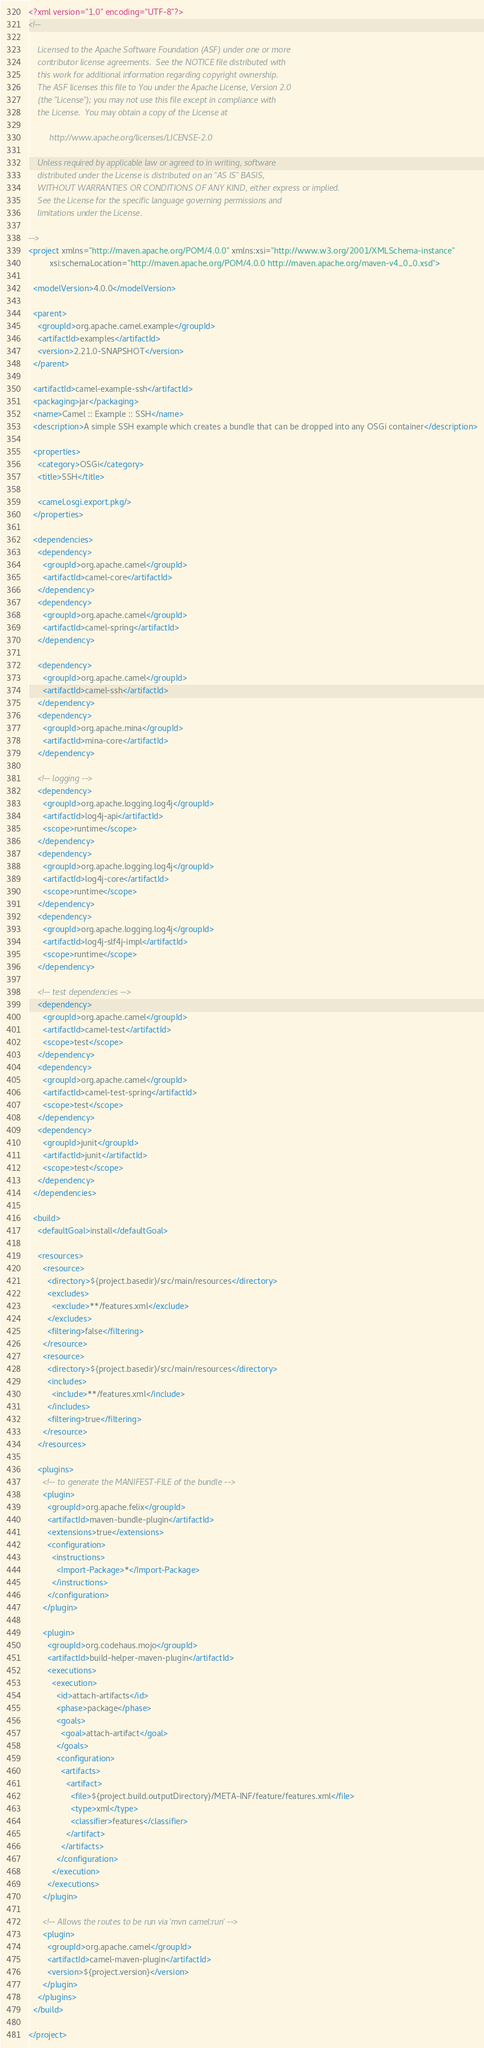<code> <loc_0><loc_0><loc_500><loc_500><_XML_><?xml version="1.0" encoding="UTF-8"?>
<!--

    Licensed to the Apache Software Foundation (ASF) under one or more
    contributor license agreements.  See the NOTICE file distributed with
    this work for additional information regarding copyright ownership.
    The ASF licenses this file to You under the Apache License, Version 2.0
    (the "License"); you may not use this file except in compliance with
    the License.  You may obtain a copy of the License at

         http://www.apache.org/licenses/LICENSE-2.0

    Unless required by applicable law or agreed to in writing, software
    distributed under the License is distributed on an "AS IS" BASIS,
    WITHOUT WARRANTIES OR CONDITIONS OF ANY KIND, either express or implied.
    See the License for the specific language governing permissions and
    limitations under the License.

-->
<project xmlns="http://maven.apache.org/POM/4.0.0" xmlns:xsi="http://www.w3.org/2001/XMLSchema-instance"
         xsi:schemaLocation="http://maven.apache.org/POM/4.0.0 http://maven.apache.org/maven-v4_0_0.xsd">

  <modelVersion>4.0.0</modelVersion>

  <parent>
    <groupId>org.apache.camel.example</groupId>
    <artifactId>examples</artifactId>
    <version>2.21.0-SNAPSHOT</version>
  </parent>

  <artifactId>camel-example-ssh</artifactId>
  <packaging>jar</packaging>
  <name>Camel :: Example :: SSH</name>
  <description>A simple SSH example which creates a bundle that can be dropped into any OSGi container</description>

  <properties>
    <category>OSGi</category>
    <title>SSH</title>

    <camel.osgi.export.pkg/>
  </properties>

  <dependencies>
    <dependency>
      <groupId>org.apache.camel</groupId>
      <artifactId>camel-core</artifactId>
    </dependency>
    <dependency>
      <groupId>org.apache.camel</groupId>
      <artifactId>camel-spring</artifactId>
    </dependency>

    <dependency>
      <groupId>org.apache.camel</groupId>
      <artifactId>camel-ssh</artifactId>
    </dependency>
    <dependency>
      <groupId>org.apache.mina</groupId>
      <artifactId>mina-core</artifactId>
    </dependency>
    
    <!-- logging -->
    <dependency>
      <groupId>org.apache.logging.log4j</groupId>
      <artifactId>log4j-api</artifactId>
      <scope>runtime</scope>
    </dependency>
    <dependency>
      <groupId>org.apache.logging.log4j</groupId>
      <artifactId>log4j-core</artifactId>
      <scope>runtime</scope>
    </dependency>
    <dependency>
      <groupId>org.apache.logging.log4j</groupId>
      <artifactId>log4j-slf4j-impl</artifactId>
      <scope>runtime</scope>
    </dependency>

    <!-- test dependencies -->
    <dependency>
      <groupId>org.apache.camel</groupId>
      <artifactId>camel-test</artifactId>
      <scope>test</scope>
    </dependency>
    <dependency>
      <groupId>org.apache.camel</groupId>
      <artifactId>camel-test-spring</artifactId>
      <scope>test</scope>
    </dependency>
    <dependency>
      <groupId>junit</groupId>
      <artifactId>junit</artifactId>
      <scope>test</scope>
    </dependency>
  </dependencies>

  <build>
    <defaultGoal>install</defaultGoal>

    <resources>
      <resource>
        <directory>${project.basedir}/src/main/resources</directory>
        <excludes>
          <exclude>**/features.xml</exclude>
        </excludes>
        <filtering>false</filtering>
      </resource>
      <resource>
        <directory>${project.basedir}/src/main/resources</directory>
        <includes>
          <include>**/features.xml</include>
        </includes>
        <filtering>true</filtering>
      </resource>
    </resources>

    <plugins>
      <!-- to generate the MANIFEST-FILE of the bundle -->
      <plugin>
        <groupId>org.apache.felix</groupId>
        <artifactId>maven-bundle-plugin</artifactId>
        <extensions>true</extensions>
        <configuration>
          <instructions>
            <Import-Package>*</Import-Package>
          </instructions>
        </configuration>
      </plugin>

      <plugin>
        <groupId>org.codehaus.mojo</groupId>
        <artifactId>build-helper-maven-plugin</artifactId>
        <executions>
          <execution>
            <id>attach-artifacts</id>
            <phase>package</phase>
            <goals>
              <goal>attach-artifact</goal>
            </goals>
            <configuration>
              <artifacts>
                <artifact>
                  <file>${project.build.outputDirectory}/META-INF/feature/features.xml</file>
                  <type>xml</type>
                  <classifier>features</classifier>
                </artifact>
              </artifacts>
            </configuration>
          </execution>
        </executions>
      </plugin>

      <!-- Allows the routes to be run via 'mvn camel:run' -->
      <plugin>
        <groupId>org.apache.camel</groupId>
        <artifactId>camel-maven-plugin</artifactId>
        <version>${project.version}</version>
      </plugin>
    </plugins>
  </build>

</project>
</code> 